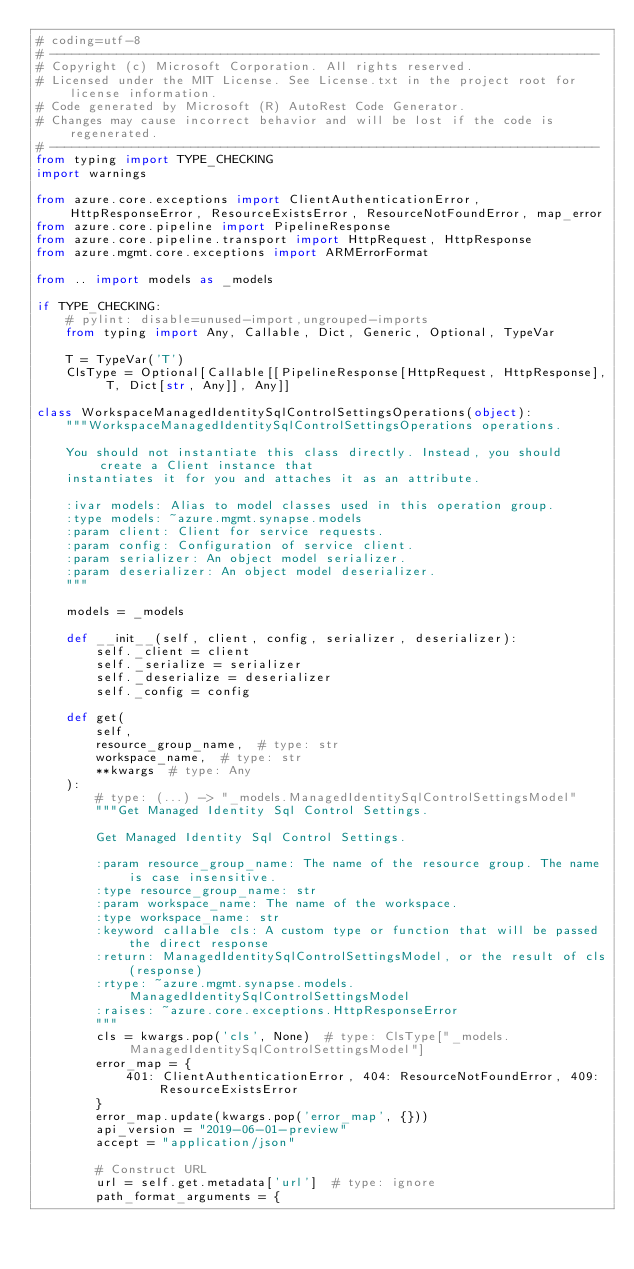Convert code to text. <code><loc_0><loc_0><loc_500><loc_500><_Python_># coding=utf-8
# --------------------------------------------------------------------------
# Copyright (c) Microsoft Corporation. All rights reserved.
# Licensed under the MIT License. See License.txt in the project root for license information.
# Code generated by Microsoft (R) AutoRest Code Generator.
# Changes may cause incorrect behavior and will be lost if the code is regenerated.
# --------------------------------------------------------------------------
from typing import TYPE_CHECKING
import warnings

from azure.core.exceptions import ClientAuthenticationError, HttpResponseError, ResourceExistsError, ResourceNotFoundError, map_error
from azure.core.pipeline import PipelineResponse
from azure.core.pipeline.transport import HttpRequest, HttpResponse
from azure.mgmt.core.exceptions import ARMErrorFormat

from .. import models as _models

if TYPE_CHECKING:
    # pylint: disable=unused-import,ungrouped-imports
    from typing import Any, Callable, Dict, Generic, Optional, TypeVar

    T = TypeVar('T')
    ClsType = Optional[Callable[[PipelineResponse[HttpRequest, HttpResponse], T, Dict[str, Any]], Any]]

class WorkspaceManagedIdentitySqlControlSettingsOperations(object):
    """WorkspaceManagedIdentitySqlControlSettingsOperations operations.

    You should not instantiate this class directly. Instead, you should create a Client instance that
    instantiates it for you and attaches it as an attribute.

    :ivar models: Alias to model classes used in this operation group.
    :type models: ~azure.mgmt.synapse.models
    :param client: Client for service requests.
    :param config: Configuration of service client.
    :param serializer: An object model serializer.
    :param deserializer: An object model deserializer.
    """

    models = _models

    def __init__(self, client, config, serializer, deserializer):
        self._client = client
        self._serialize = serializer
        self._deserialize = deserializer
        self._config = config

    def get(
        self,
        resource_group_name,  # type: str
        workspace_name,  # type: str
        **kwargs  # type: Any
    ):
        # type: (...) -> "_models.ManagedIdentitySqlControlSettingsModel"
        """Get Managed Identity Sql Control Settings.

        Get Managed Identity Sql Control Settings.

        :param resource_group_name: The name of the resource group. The name is case insensitive.
        :type resource_group_name: str
        :param workspace_name: The name of the workspace.
        :type workspace_name: str
        :keyword callable cls: A custom type or function that will be passed the direct response
        :return: ManagedIdentitySqlControlSettingsModel, or the result of cls(response)
        :rtype: ~azure.mgmt.synapse.models.ManagedIdentitySqlControlSettingsModel
        :raises: ~azure.core.exceptions.HttpResponseError
        """
        cls = kwargs.pop('cls', None)  # type: ClsType["_models.ManagedIdentitySqlControlSettingsModel"]
        error_map = {
            401: ClientAuthenticationError, 404: ResourceNotFoundError, 409: ResourceExistsError
        }
        error_map.update(kwargs.pop('error_map', {}))
        api_version = "2019-06-01-preview"
        accept = "application/json"

        # Construct URL
        url = self.get.metadata['url']  # type: ignore
        path_format_arguments = {</code> 